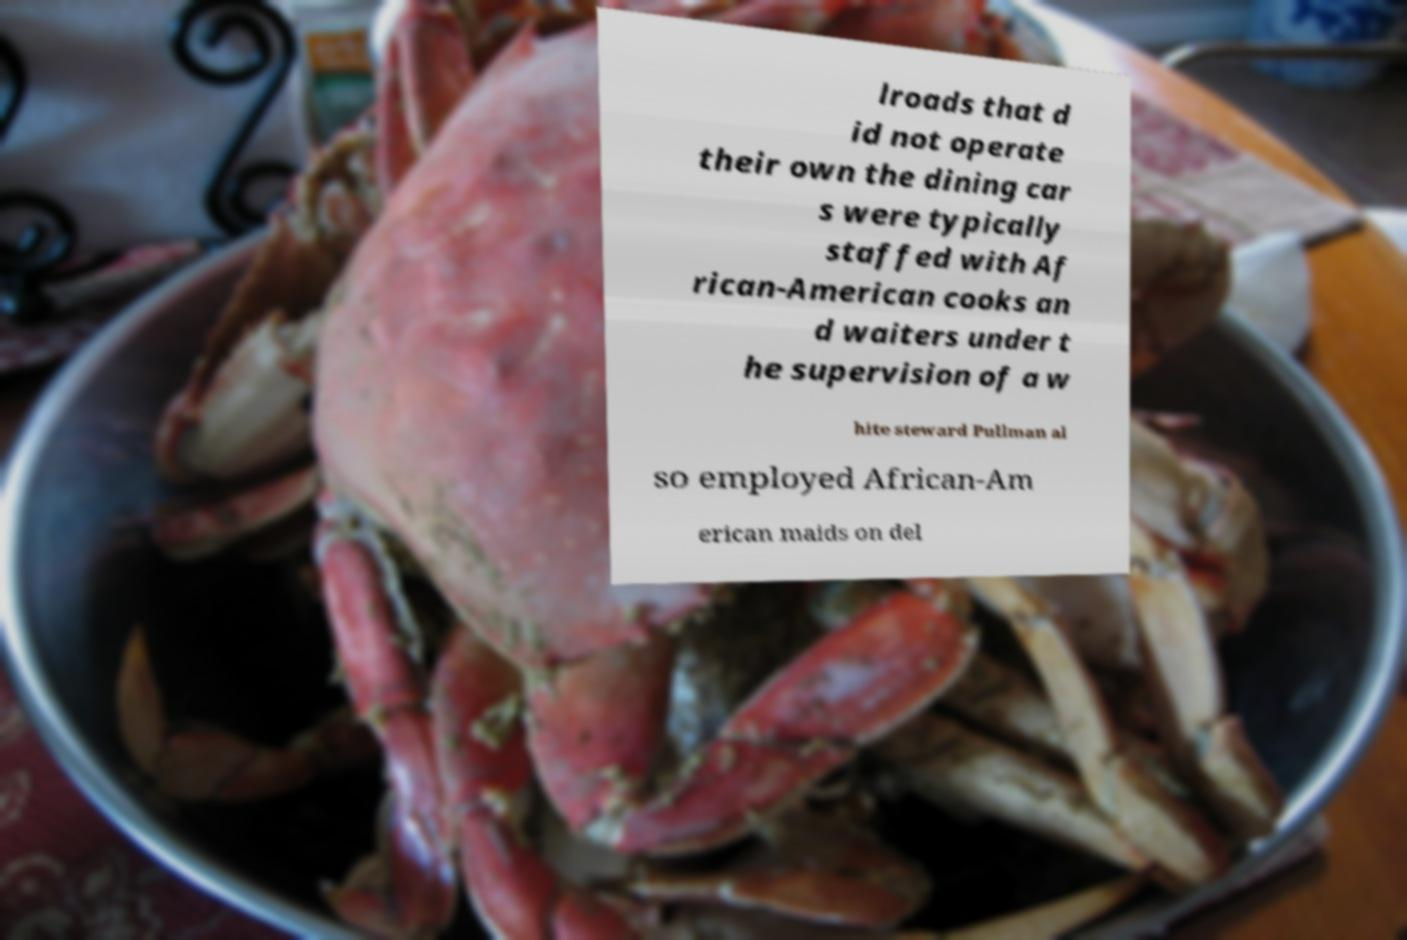What messages or text are displayed in this image? I need them in a readable, typed format. lroads that d id not operate their own the dining car s were typically staffed with Af rican-American cooks an d waiters under t he supervision of a w hite steward Pullman al so employed African-Am erican maids on del 